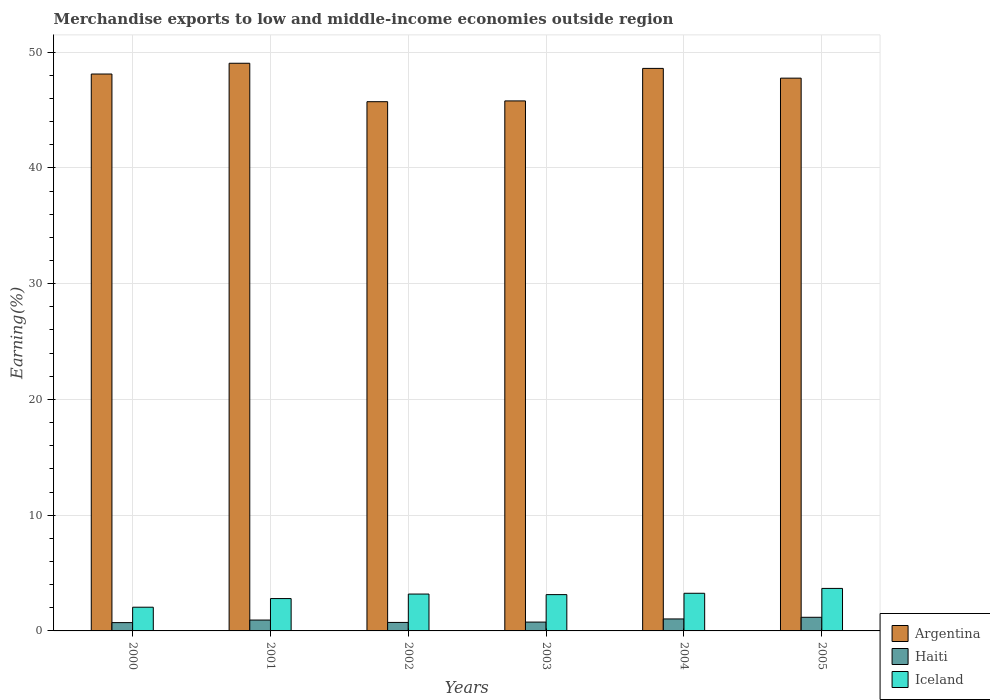How many different coloured bars are there?
Provide a succinct answer. 3. In how many cases, is the number of bars for a given year not equal to the number of legend labels?
Make the answer very short. 0. What is the percentage of amount earned from merchandise exports in Argentina in 2002?
Your response must be concise. 45.72. Across all years, what is the maximum percentage of amount earned from merchandise exports in Haiti?
Offer a terse response. 1.18. Across all years, what is the minimum percentage of amount earned from merchandise exports in Argentina?
Your response must be concise. 45.72. In which year was the percentage of amount earned from merchandise exports in Argentina minimum?
Offer a terse response. 2002. What is the total percentage of amount earned from merchandise exports in Iceland in the graph?
Your answer should be very brief. 18.09. What is the difference between the percentage of amount earned from merchandise exports in Argentina in 2001 and that in 2005?
Give a very brief answer. 1.29. What is the difference between the percentage of amount earned from merchandise exports in Iceland in 2003 and the percentage of amount earned from merchandise exports in Argentina in 2002?
Ensure brevity in your answer.  -42.59. What is the average percentage of amount earned from merchandise exports in Argentina per year?
Offer a terse response. 47.5. In the year 2004, what is the difference between the percentage of amount earned from merchandise exports in Argentina and percentage of amount earned from merchandise exports in Haiti?
Offer a terse response. 47.56. In how many years, is the percentage of amount earned from merchandise exports in Iceland greater than 8 %?
Provide a succinct answer. 0. What is the ratio of the percentage of amount earned from merchandise exports in Argentina in 2003 to that in 2005?
Give a very brief answer. 0.96. Is the difference between the percentage of amount earned from merchandise exports in Argentina in 2001 and 2002 greater than the difference between the percentage of amount earned from merchandise exports in Haiti in 2001 and 2002?
Give a very brief answer. Yes. What is the difference between the highest and the second highest percentage of amount earned from merchandise exports in Haiti?
Your answer should be compact. 0.14. What is the difference between the highest and the lowest percentage of amount earned from merchandise exports in Haiti?
Keep it short and to the point. 0.46. In how many years, is the percentage of amount earned from merchandise exports in Iceland greater than the average percentage of amount earned from merchandise exports in Iceland taken over all years?
Make the answer very short. 4. Is it the case that in every year, the sum of the percentage of amount earned from merchandise exports in Iceland and percentage of amount earned from merchandise exports in Argentina is greater than the percentage of amount earned from merchandise exports in Haiti?
Your answer should be compact. Yes. How many bars are there?
Provide a short and direct response. 18. Are all the bars in the graph horizontal?
Ensure brevity in your answer.  No. How many years are there in the graph?
Give a very brief answer. 6. Are the values on the major ticks of Y-axis written in scientific E-notation?
Keep it short and to the point. No. Does the graph contain grids?
Offer a terse response. Yes. Where does the legend appear in the graph?
Offer a terse response. Bottom right. How many legend labels are there?
Offer a terse response. 3. What is the title of the graph?
Make the answer very short. Merchandise exports to low and middle-income economies outside region. What is the label or title of the X-axis?
Offer a terse response. Years. What is the label or title of the Y-axis?
Make the answer very short. Earning(%). What is the Earning(%) of Argentina in 2000?
Your answer should be compact. 48.11. What is the Earning(%) of Haiti in 2000?
Keep it short and to the point. 0.72. What is the Earning(%) of Iceland in 2000?
Provide a succinct answer. 2.05. What is the Earning(%) in Argentina in 2001?
Your answer should be very brief. 49.04. What is the Earning(%) in Haiti in 2001?
Make the answer very short. 0.94. What is the Earning(%) in Iceland in 2001?
Your response must be concise. 2.79. What is the Earning(%) of Argentina in 2002?
Ensure brevity in your answer.  45.72. What is the Earning(%) of Haiti in 2002?
Offer a terse response. 0.73. What is the Earning(%) in Iceland in 2002?
Provide a short and direct response. 3.19. What is the Earning(%) of Argentina in 2003?
Offer a terse response. 45.79. What is the Earning(%) in Haiti in 2003?
Make the answer very short. 0.76. What is the Earning(%) in Iceland in 2003?
Your answer should be compact. 3.14. What is the Earning(%) in Argentina in 2004?
Offer a very short reply. 48.6. What is the Earning(%) in Haiti in 2004?
Provide a succinct answer. 1.03. What is the Earning(%) in Iceland in 2004?
Provide a succinct answer. 3.25. What is the Earning(%) in Argentina in 2005?
Your response must be concise. 47.75. What is the Earning(%) of Haiti in 2005?
Your answer should be very brief. 1.18. What is the Earning(%) of Iceland in 2005?
Give a very brief answer. 3.67. Across all years, what is the maximum Earning(%) in Argentina?
Offer a very short reply. 49.04. Across all years, what is the maximum Earning(%) of Haiti?
Keep it short and to the point. 1.18. Across all years, what is the maximum Earning(%) in Iceland?
Provide a short and direct response. 3.67. Across all years, what is the minimum Earning(%) in Argentina?
Offer a very short reply. 45.72. Across all years, what is the minimum Earning(%) in Haiti?
Offer a terse response. 0.72. Across all years, what is the minimum Earning(%) of Iceland?
Your answer should be compact. 2.05. What is the total Earning(%) of Argentina in the graph?
Offer a very short reply. 285.01. What is the total Earning(%) of Haiti in the graph?
Ensure brevity in your answer.  5.37. What is the total Earning(%) of Iceland in the graph?
Make the answer very short. 18.09. What is the difference between the Earning(%) of Argentina in 2000 and that in 2001?
Your answer should be very brief. -0.93. What is the difference between the Earning(%) in Haiti in 2000 and that in 2001?
Make the answer very short. -0.22. What is the difference between the Earning(%) in Iceland in 2000 and that in 2001?
Your answer should be compact. -0.75. What is the difference between the Earning(%) of Argentina in 2000 and that in 2002?
Provide a succinct answer. 2.39. What is the difference between the Earning(%) in Haiti in 2000 and that in 2002?
Make the answer very short. -0.02. What is the difference between the Earning(%) in Iceland in 2000 and that in 2002?
Ensure brevity in your answer.  -1.14. What is the difference between the Earning(%) of Argentina in 2000 and that in 2003?
Provide a short and direct response. 2.32. What is the difference between the Earning(%) in Haiti in 2000 and that in 2003?
Keep it short and to the point. -0.05. What is the difference between the Earning(%) in Iceland in 2000 and that in 2003?
Your answer should be very brief. -1.09. What is the difference between the Earning(%) in Argentina in 2000 and that in 2004?
Your response must be concise. -0.49. What is the difference between the Earning(%) in Haiti in 2000 and that in 2004?
Make the answer very short. -0.32. What is the difference between the Earning(%) in Iceland in 2000 and that in 2004?
Your answer should be compact. -1.2. What is the difference between the Earning(%) of Argentina in 2000 and that in 2005?
Your response must be concise. 0.36. What is the difference between the Earning(%) in Haiti in 2000 and that in 2005?
Provide a short and direct response. -0.46. What is the difference between the Earning(%) in Iceland in 2000 and that in 2005?
Keep it short and to the point. -1.62. What is the difference between the Earning(%) in Argentina in 2001 and that in 2002?
Your answer should be very brief. 3.32. What is the difference between the Earning(%) of Haiti in 2001 and that in 2002?
Ensure brevity in your answer.  0.2. What is the difference between the Earning(%) in Iceland in 2001 and that in 2002?
Keep it short and to the point. -0.39. What is the difference between the Earning(%) in Argentina in 2001 and that in 2003?
Your answer should be compact. 3.25. What is the difference between the Earning(%) of Haiti in 2001 and that in 2003?
Make the answer very short. 0.18. What is the difference between the Earning(%) of Iceland in 2001 and that in 2003?
Provide a short and direct response. -0.34. What is the difference between the Earning(%) in Argentina in 2001 and that in 2004?
Provide a short and direct response. 0.44. What is the difference between the Earning(%) in Haiti in 2001 and that in 2004?
Keep it short and to the point. -0.1. What is the difference between the Earning(%) in Iceland in 2001 and that in 2004?
Ensure brevity in your answer.  -0.46. What is the difference between the Earning(%) in Argentina in 2001 and that in 2005?
Offer a terse response. 1.29. What is the difference between the Earning(%) in Haiti in 2001 and that in 2005?
Make the answer very short. -0.24. What is the difference between the Earning(%) of Iceland in 2001 and that in 2005?
Your answer should be very brief. -0.88. What is the difference between the Earning(%) in Argentina in 2002 and that in 2003?
Give a very brief answer. -0.07. What is the difference between the Earning(%) in Haiti in 2002 and that in 2003?
Offer a very short reply. -0.03. What is the difference between the Earning(%) in Iceland in 2002 and that in 2003?
Your answer should be compact. 0.05. What is the difference between the Earning(%) of Argentina in 2002 and that in 2004?
Offer a very short reply. -2.88. What is the difference between the Earning(%) in Haiti in 2002 and that in 2004?
Make the answer very short. -0.3. What is the difference between the Earning(%) of Iceland in 2002 and that in 2004?
Your response must be concise. -0.07. What is the difference between the Earning(%) of Argentina in 2002 and that in 2005?
Ensure brevity in your answer.  -2.03. What is the difference between the Earning(%) of Haiti in 2002 and that in 2005?
Give a very brief answer. -0.44. What is the difference between the Earning(%) of Iceland in 2002 and that in 2005?
Keep it short and to the point. -0.49. What is the difference between the Earning(%) of Argentina in 2003 and that in 2004?
Keep it short and to the point. -2.81. What is the difference between the Earning(%) of Haiti in 2003 and that in 2004?
Provide a short and direct response. -0.27. What is the difference between the Earning(%) of Iceland in 2003 and that in 2004?
Make the answer very short. -0.12. What is the difference between the Earning(%) of Argentina in 2003 and that in 2005?
Your answer should be very brief. -1.97. What is the difference between the Earning(%) of Haiti in 2003 and that in 2005?
Provide a short and direct response. -0.41. What is the difference between the Earning(%) of Iceland in 2003 and that in 2005?
Offer a terse response. -0.54. What is the difference between the Earning(%) of Argentina in 2004 and that in 2005?
Your answer should be very brief. 0.84. What is the difference between the Earning(%) in Haiti in 2004 and that in 2005?
Your answer should be very brief. -0.14. What is the difference between the Earning(%) in Iceland in 2004 and that in 2005?
Your answer should be very brief. -0.42. What is the difference between the Earning(%) in Argentina in 2000 and the Earning(%) in Haiti in 2001?
Give a very brief answer. 47.17. What is the difference between the Earning(%) in Argentina in 2000 and the Earning(%) in Iceland in 2001?
Make the answer very short. 45.32. What is the difference between the Earning(%) in Haiti in 2000 and the Earning(%) in Iceland in 2001?
Keep it short and to the point. -2.08. What is the difference between the Earning(%) of Argentina in 2000 and the Earning(%) of Haiti in 2002?
Ensure brevity in your answer.  47.38. What is the difference between the Earning(%) in Argentina in 2000 and the Earning(%) in Iceland in 2002?
Offer a terse response. 44.93. What is the difference between the Earning(%) of Haiti in 2000 and the Earning(%) of Iceland in 2002?
Provide a short and direct response. -2.47. What is the difference between the Earning(%) in Argentina in 2000 and the Earning(%) in Haiti in 2003?
Offer a terse response. 47.35. What is the difference between the Earning(%) of Argentina in 2000 and the Earning(%) of Iceland in 2003?
Your answer should be compact. 44.98. What is the difference between the Earning(%) in Haiti in 2000 and the Earning(%) in Iceland in 2003?
Keep it short and to the point. -2.42. What is the difference between the Earning(%) in Argentina in 2000 and the Earning(%) in Haiti in 2004?
Give a very brief answer. 47.08. What is the difference between the Earning(%) of Argentina in 2000 and the Earning(%) of Iceland in 2004?
Ensure brevity in your answer.  44.86. What is the difference between the Earning(%) of Haiti in 2000 and the Earning(%) of Iceland in 2004?
Your answer should be compact. -2.54. What is the difference between the Earning(%) in Argentina in 2000 and the Earning(%) in Haiti in 2005?
Your answer should be compact. 46.93. What is the difference between the Earning(%) in Argentina in 2000 and the Earning(%) in Iceland in 2005?
Offer a very short reply. 44.44. What is the difference between the Earning(%) in Haiti in 2000 and the Earning(%) in Iceland in 2005?
Your answer should be very brief. -2.96. What is the difference between the Earning(%) in Argentina in 2001 and the Earning(%) in Haiti in 2002?
Make the answer very short. 48.31. What is the difference between the Earning(%) of Argentina in 2001 and the Earning(%) of Iceland in 2002?
Keep it short and to the point. 45.86. What is the difference between the Earning(%) of Haiti in 2001 and the Earning(%) of Iceland in 2002?
Ensure brevity in your answer.  -2.25. What is the difference between the Earning(%) of Argentina in 2001 and the Earning(%) of Haiti in 2003?
Provide a short and direct response. 48.28. What is the difference between the Earning(%) of Argentina in 2001 and the Earning(%) of Iceland in 2003?
Keep it short and to the point. 45.91. What is the difference between the Earning(%) in Haiti in 2001 and the Earning(%) in Iceland in 2003?
Your answer should be very brief. -2.2. What is the difference between the Earning(%) in Argentina in 2001 and the Earning(%) in Haiti in 2004?
Offer a terse response. 48.01. What is the difference between the Earning(%) in Argentina in 2001 and the Earning(%) in Iceland in 2004?
Give a very brief answer. 45.79. What is the difference between the Earning(%) in Haiti in 2001 and the Earning(%) in Iceland in 2004?
Offer a very short reply. -2.31. What is the difference between the Earning(%) of Argentina in 2001 and the Earning(%) of Haiti in 2005?
Your response must be concise. 47.86. What is the difference between the Earning(%) of Argentina in 2001 and the Earning(%) of Iceland in 2005?
Provide a short and direct response. 45.37. What is the difference between the Earning(%) in Haiti in 2001 and the Earning(%) in Iceland in 2005?
Offer a very short reply. -2.73. What is the difference between the Earning(%) of Argentina in 2002 and the Earning(%) of Haiti in 2003?
Make the answer very short. 44.96. What is the difference between the Earning(%) of Argentina in 2002 and the Earning(%) of Iceland in 2003?
Provide a short and direct response. 42.59. What is the difference between the Earning(%) in Haiti in 2002 and the Earning(%) in Iceland in 2003?
Make the answer very short. -2.4. What is the difference between the Earning(%) of Argentina in 2002 and the Earning(%) of Haiti in 2004?
Give a very brief answer. 44.69. What is the difference between the Earning(%) in Argentina in 2002 and the Earning(%) in Iceland in 2004?
Provide a short and direct response. 42.47. What is the difference between the Earning(%) in Haiti in 2002 and the Earning(%) in Iceland in 2004?
Your response must be concise. -2.52. What is the difference between the Earning(%) in Argentina in 2002 and the Earning(%) in Haiti in 2005?
Ensure brevity in your answer.  44.54. What is the difference between the Earning(%) of Argentina in 2002 and the Earning(%) of Iceland in 2005?
Offer a very short reply. 42.05. What is the difference between the Earning(%) in Haiti in 2002 and the Earning(%) in Iceland in 2005?
Keep it short and to the point. -2.94. What is the difference between the Earning(%) of Argentina in 2003 and the Earning(%) of Haiti in 2004?
Your answer should be compact. 44.75. What is the difference between the Earning(%) of Argentina in 2003 and the Earning(%) of Iceland in 2004?
Keep it short and to the point. 42.54. What is the difference between the Earning(%) of Haiti in 2003 and the Earning(%) of Iceland in 2004?
Offer a terse response. -2.49. What is the difference between the Earning(%) in Argentina in 2003 and the Earning(%) in Haiti in 2005?
Provide a short and direct response. 44.61. What is the difference between the Earning(%) of Argentina in 2003 and the Earning(%) of Iceland in 2005?
Give a very brief answer. 42.12. What is the difference between the Earning(%) in Haiti in 2003 and the Earning(%) in Iceland in 2005?
Give a very brief answer. -2.91. What is the difference between the Earning(%) in Argentina in 2004 and the Earning(%) in Haiti in 2005?
Provide a succinct answer. 47.42. What is the difference between the Earning(%) in Argentina in 2004 and the Earning(%) in Iceland in 2005?
Give a very brief answer. 44.92. What is the difference between the Earning(%) in Haiti in 2004 and the Earning(%) in Iceland in 2005?
Ensure brevity in your answer.  -2.64. What is the average Earning(%) of Argentina per year?
Make the answer very short. 47.5. What is the average Earning(%) of Haiti per year?
Offer a terse response. 0.89. What is the average Earning(%) in Iceland per year?
Ensure brevity in your answer.  3.02. In the year 2000, what is the difference between the Earning(%) in Argentina and Earning(%) in Haiti?
Make the answer very short. 47.39. In the year 2000, what is the difference between the Earning(%) of Argentina and Earning(%) of Iceland?
Your answer should be compact. 46.06. In the year 2000, what is the difference between the Earning(%) of Haiti and Earning(%) of Iceland?
Keep it short and to the point. -1.33. In the year 2001, what is the difference between the Earning(%) of Argentina and Earning(%) of Haiti?
Give a very brief answer. 48.1. In the year 2001, what is the difference between the Earning(%) in Argentina and Earning(%) in Iceland?
Ensure brevity in your answer.  46.25. In the year 2001, what is the difference between the Earning(%) of Haiti and Earning(%) of Iceland?
Your response must be concise. -1.86. In the year 2002, what is the difference between the Earning(%) of Argentina and Earning(%) of Haiti?
Ensure brevity in your answer.  44.99. In the year 2002, what is the difference between the Earning(%) of Argentina and Earning(%) of Iceland?
Your answer should be compact. 42.54. In the year 2002, what is the difference between the Earning(%) of Haiti and Earning(%) of Iceland?
Make the answer very short. -2.45. In the year 2003, what is the difference between the Earning(%) in Argentina and Earning(%) in Haiti?
Make the answer very short. 45.02. In the year 2003, what is the difference between the Earning(%) in Argentina and Earning(%) in Iceland?
Offer a very short reply. 42.65. In the year 2003, what is the difference between the Earning(%) of Haiti and Earning(%) of Iceland?
Make the answer very short. -2.37. In the year 2004, what is the difference between the Earning(%) in Argentina and Earning(%) in Haiti?
Offer a terse response. 47.56. In the year 2004, what is the difference between the Earning(%) in Argentina and Earning(%) in Iceland?
Offer a terse response. 45.34. In the year 2004, what is the difference between the Earning(%) of Haiti and Earning(%) of Iceland?
Give a very brief answer. -2.22. In the year 2005, what is the difference between the Earning(%) in Argentina and Earning(%) in Haiti?
Your response must be concise. 46.58. In the year 2005, what is the difference between the Earning(%) in Argentina and Earning(%) in Iceland?
Offer a terse response. 44.08. In the year 2005, what is the difference between the Earning(%) of Haiti and Earning(%) of Iceland?
Provide a short and direct response. -2.5. What is the ratio of the Earning(%) in Argentina in 2000 to that in 2001?
Offer a very short reply. 0.98. What is the ratio of the Earning(%) of Haiti in 2000 to that in 2001?
Provide a succinct answer. 0.76. What is the ratio of the Earning(%) in Iceland in 2000 to that in 2001?
Your answer should be compact. 0.73. What is the ratio of the Earning(%) in Argentina in 2000 to that in 2002?
Offer a terse response. 1.05. What is the ratio of the Earning(%) of Haiti in 2000 to that in 2002?
Provide a short and direct response. 0.98. What is the ratio of the Earning(%) of Iceland in 2000 to that in 2002?
Offer a terse response. 0.64. What is the ratio of the Earning(%) of Argentina in 2000 to that in 2003?
Offer a terse response. 1.05. What is the ratio of the Earning(%) of Haiti in 2000 to that in 2003?
Offer a very short reply. 0.94. What is the ratio of the Earning(%) of Iceland in 2000 to that in 2003?
Provide a succinct answer. 0.65. What is the ratio of the Earning(%) of Argentina in 2000 to that in 2004?
Offer a very short reply. 0.99. What is the ratio of the Earning(%) in Haiti in 2000 to that in 2004?
Your answer should be very brief. 0.69. What is the ratio of the Earning(%) in Iceland in 2000 to that in 2004?
Your answer should be compact. 0.63. What is the ratio of the Earning(%) in Argentina in 2000 to that in 2005?
Your answer should be very brief. 1.01. What is the ratio of the Earning(%) in Haiti in 2000 to that in 2005?
Provide a short and direct response. 0.61. What is the ratio of the Earning(%) of Iceland in 2000 to that in 2005?
Your answer should be compact. 0.56. What is the ratio of the Earning(%) in Argentina in 2001 to that in 2002?
Ensure brevity in your answer.  1.07. What is the ratio of the Earning(%) of Haiti in 2001 to that in 2002?
Provide a short and direct response. 1.28. What is the ratio of the Earning(%) of Iceland in 2001 to that in 2002?
Ensure brevity in your answer.  0.88. What is the ratio of the Earning(%) in Argentina in 2001 to that in 2003?
Your answer should be compact. 1.07. What is the ratio of the Earning(%) in Haiti in 2001 to that in 2003?
Offer a very short reply. 1.23. What is the ratio of the Earning(%) in Iceland in 2001 to that in 2003?
Provide a short and direct response. 0.89. What is the ratio of the Earning(%) of Argentina in 2001 to that in 2004?
Your answer should be very brief. 1.01. What is the ratio of the Earning(%) in Haiti in 2001 to that in 2004?
Make the answer very short. 0.91. What is the ratio of the Earning(%) of Iceland in 2001 to that in 2004?
Your answer should be very brief. 0.86. What is the ratio of the Earning(%) in Argentina in 2001 to that in 2005?
Your answer should be compact. 1.03. What is the ratio of the Earning(%) in Haiti in 2001 to that in 2005?
Offer a very short reply. 0.8. What is the ratio of the Earning(%) in Iceland in 2001 to that in 2005?
Give a very brief answer. 0.76. What is the ratio of the Earning(%) of Argentina in 2002 to that in 2003?
Offer a terse response. 1. What is the ratio of the Earning(%) of Haiti in 2002 to that in 2003?
Offer a terse response. 0.96. What is the ratio of the Earning(%) of Iceland in 2002 to that in 2003?
Offer a terse response. 1.02. What is the ratio of the Earning(%) of Argentina in 2002 to that in 2004?
Offer a very short reply. 0.94. What is the ratio of the Earning(%) of Haiti in 2002 to that in 2004?
Offer a very short reply. 0.71. What is the ratio of the Earning(%) in Iceland in 2002 to that in 2004?
Ensure brevity in your answer.  0.98. What is the ratio of the Earning(%) in Argentina in 2002 to that in 2005?
Provide a succinct answer. 0.96. What is the ratio of the Earning(%) of Haiti in 2002 to that in 2005?
Provide a succinct answer. 0.62. What is the ratio of the Earning(%) in Iceland in 2002 to that in 2005?
Provide a succinct answer. 0.87. What is the ratio of the Earning(%) of Argentina in 2003 to that in 2004?
Your answer should be compact. 0.94. What is the ratio of the Earning(%) of Haiti in 2003 to that in 2004?
Your answer should be very brief. 0.74. What is the ratio of the Earning(%) in Iceland in 2003 to that in 2004?
Your answer should be compact. 0.96. What is the ratio of the Earning(%) in Argentina in 2003 to that in 2005?
Keep it short and to the point. 0.96. What is the ratio of the Earning(%) of Haiti in 2003 to that in 2005?
Give a very brief answer. 0.65. What is the ratio of the Earning(%) of Iceland in 2003 to that in 2005?
Provide a succinct answer. 0.85. What is the ratio of the Earning(%) in Argentina in 2004 to that in 2005?
Make the answer very short. 1.02. What is the ratio of the Earning(%) in Haiti in 2004 to that in 2005?
Offer a terse response. 0.88. What is the ratio of the Earning(%) of Iceland in 2004 to that in 2005?
Provide a succinct answer. 0.89. What is the difference between the highest and the second highest Earning(%) of Argentina?
Offer a terse response. 0.44. What is the difference between the highest and the second highest Earning(%) in Haiti?
Give a very brief answer. 0.14. What is the difference between the highest and the second highest Earning(%) in Iceland?
Give a very brief answer. 0.42. What is the difference between the highest and the lowest Earning(%) in Argentina?
Offer a terse response. 3.32. What is the difference between the highest and the lowest Earning(%) in Haiti?
Provide a short and direct response. 0.46. What is the difference between the highest and the lowest Earning(%) of Iceland?
Offer a very short reply. 1.62. 